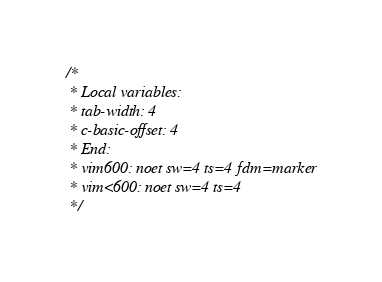Convert code to text. <code><loc_0><loc_0><loc_500><loc_500><_C_>/*
 * Local variables:
 * tab-width: 4
 * c-basic-offset: 4
 * End:
 * vim600: noet sw=4 ts=4 fdm=marker
 * vim<600: noet sw=4 ts=4
 */
</code> 